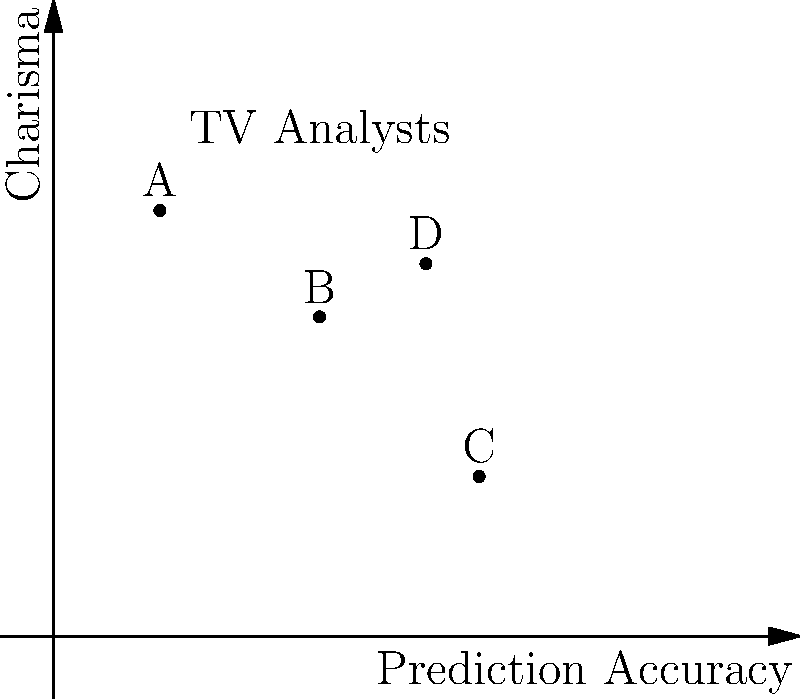In the graph above, four TV analysts (A, B, C, and D) are plotted based on their prediction accuracy (x-axis) and charisma (y-axis). Which analyst would you most likely prefer to watch, considering your desire for both accurate predictions and engaging presentations? To determine the preferred analyst, we need to consider both prediction accuracy and charisma:

1. Analyst A: Low accuracy (2), high charisma (8)
2. Analyst B: Moderate accuracy (5), moderate charisma (6)
3. Analyst C: High accuracy (8), low charisma (3)
4. Analyst D: High accuracy (7), high charisma (7)

As a proud homemaker who arranges their schedule around analysts' broadcasts and roots for them to be right, you would likely prefer an analyst with both high accuracy and high charisma.

Analyst D has the best combination of high prediction accuracy (7 out of 10) and high charisma (7 out of 10). This analyst would provide both reliable predictions and an engaging presentation style, making them the most appealing choice for someone who values both aspects.

While Analyst C has slightly higher accuracy, their charisma is significantly lower, which might make their broadcasts less engaging. Analysts A and B fall short in either accuracy or charisma compared to Analyst D.
Answer: Analyst D 